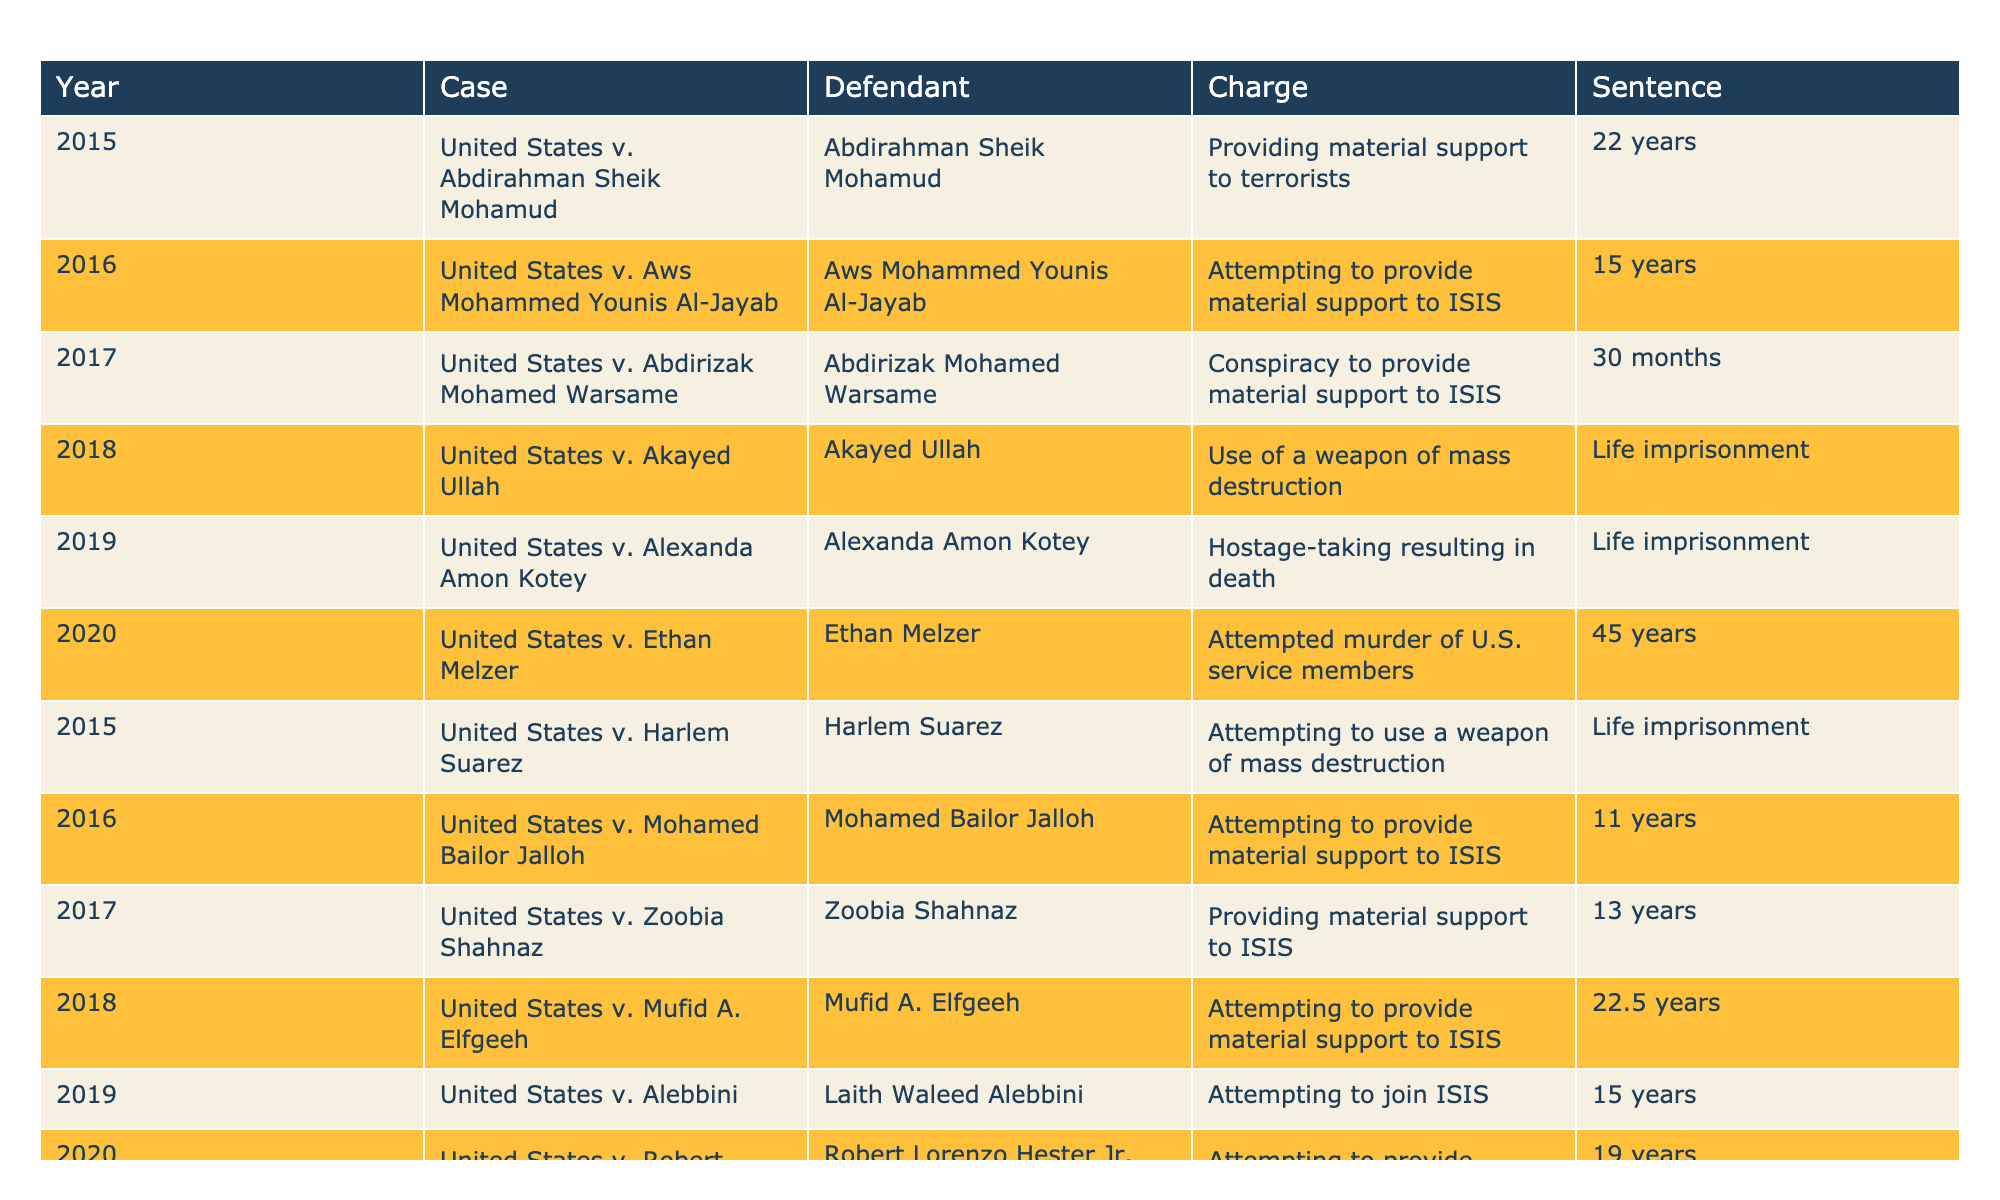What is the longest sentence given in the national security prosecutions from 2015 to 2020? The table displays various cases along with their corresponding sentences. Searching through the sentences, the longest one is "Life imprisonment," which is given to Akayed Ullah and Harlem Suarez.
Answer: Life imprisonment How many cases in 2016 resulted in felony charges related to providing material support to terrorism? In 2016, there are two cases: United States v. Aws Mohammed Younis Al-Jayab and United States v. Mohamed Bailor Jalloh. Both charged attempting to provide material support to ISIS.
Answer: 2 Which defendant received a sentence of 30 months, and what was their charge? Abdirizak Mohamed Warsame received a sentence of 30 months for his charge of conspiracy to provide material support to ISIS. This information is located in the row corresponding to 2017.
Answer: Abdirizak Mohamed Warsame, conspiracy to provide material support to ISIS What is the average sentence duration for cases in 2019? The sentences from 2019 are: "Life imprisonment," "15 years," and "45 years." Since "Life imprisonment" doesn't contribute numeric value, only "15 years" and "45 years" are used. Summing these yields 60 years over 2 cases, thus 60/2 = 30 is the average.
Answer: 30 years Were there any cases in 2018 that resulted in a sentence of less than 20 years? By examining the table for 2018, we find two cases: Akayed Ullah received "Life imprisonment" and Mufid A. Elfgeeh received "22.5 years." Both are greater than 20 years, meaning no cases were sentenced less.
Answer: No Which year had the highest number of prosecutions for national security cases? Counting the entries in each year's prosecution, 2015, 2016, 2017, 2018, 2019, and 2020 each have 2 cases except for 2017, which only has 1. Therefore, both 2015 and 2016 with 2 cases are the highest.
Answer: 2015 and 2016 Did any case charge relate specifically to hostage-taking, and what was the corresponding sentence? Inspecting the table, only the case of Alexanda Amon Kotey in 2019 mentions hostage-taking. Their sentence is noted as "Life imprisonment."
Answer: Yes, Life imprisonment How many defendants received a sentence of over 20 years? The following sentences exceed 20 years: "22 years," "Life imprisonment," and "30 months." Overall, counting each case, we find 6 cases above 20 years, confirming that 5 defendants received lengthy sentences according to the data from the table.
Answer: 6 